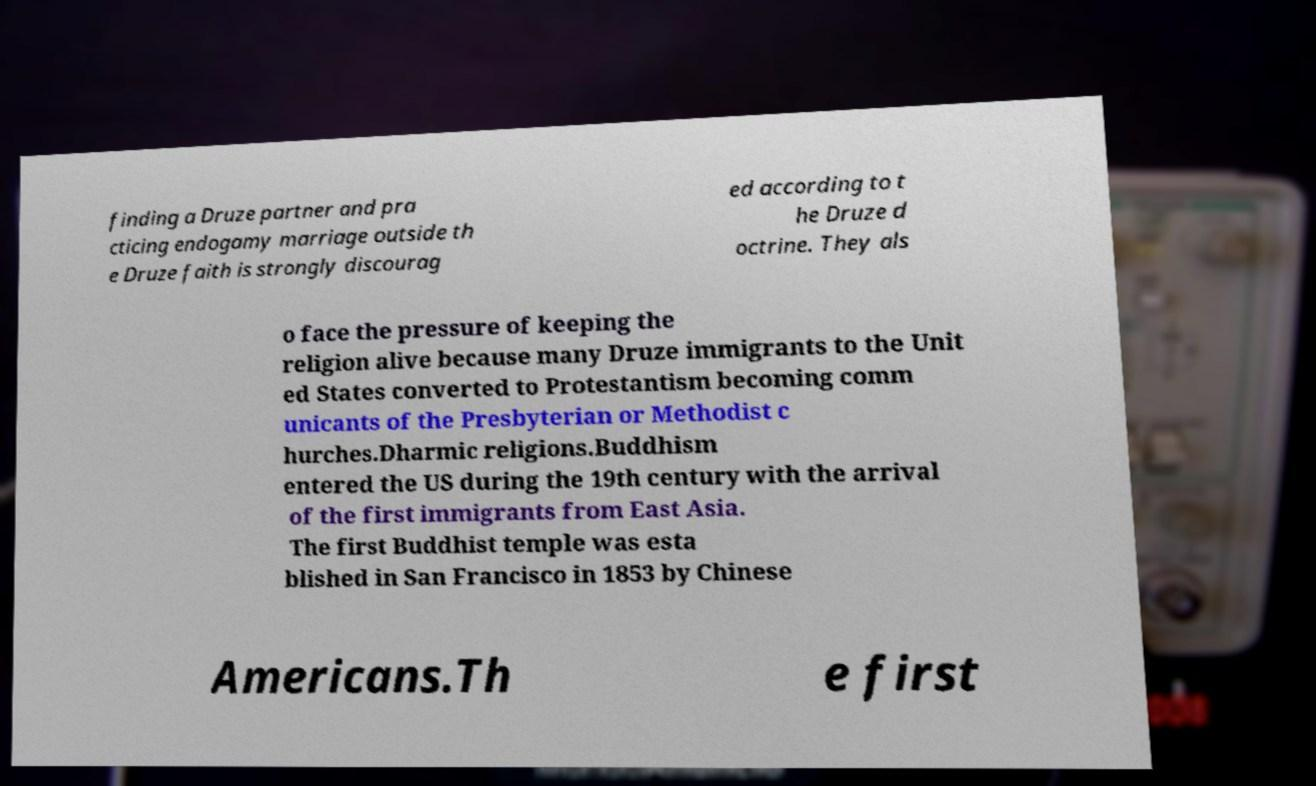There's text embedded in this image that I need extracted. Can you transcribe it verbatim? finding a Druze partner and pra cticing endogamy marriage outside th e Druze faith is strongly discourag ed according to t he Druze d octrine. They als o face the pressure of keeping the religion alive because many Druze immigrants to the Unit ed States converted to Protestantism becoming comm unicants of the Presbyterian or Methodist c hurches.Dharmic religions.Buddhism entered the US during the 19th century with the arrival of the first immigrants from East Asia. The first Buddhist temple was esta blished in San Francisco in 1853 by Chinese Americans.Th e first 